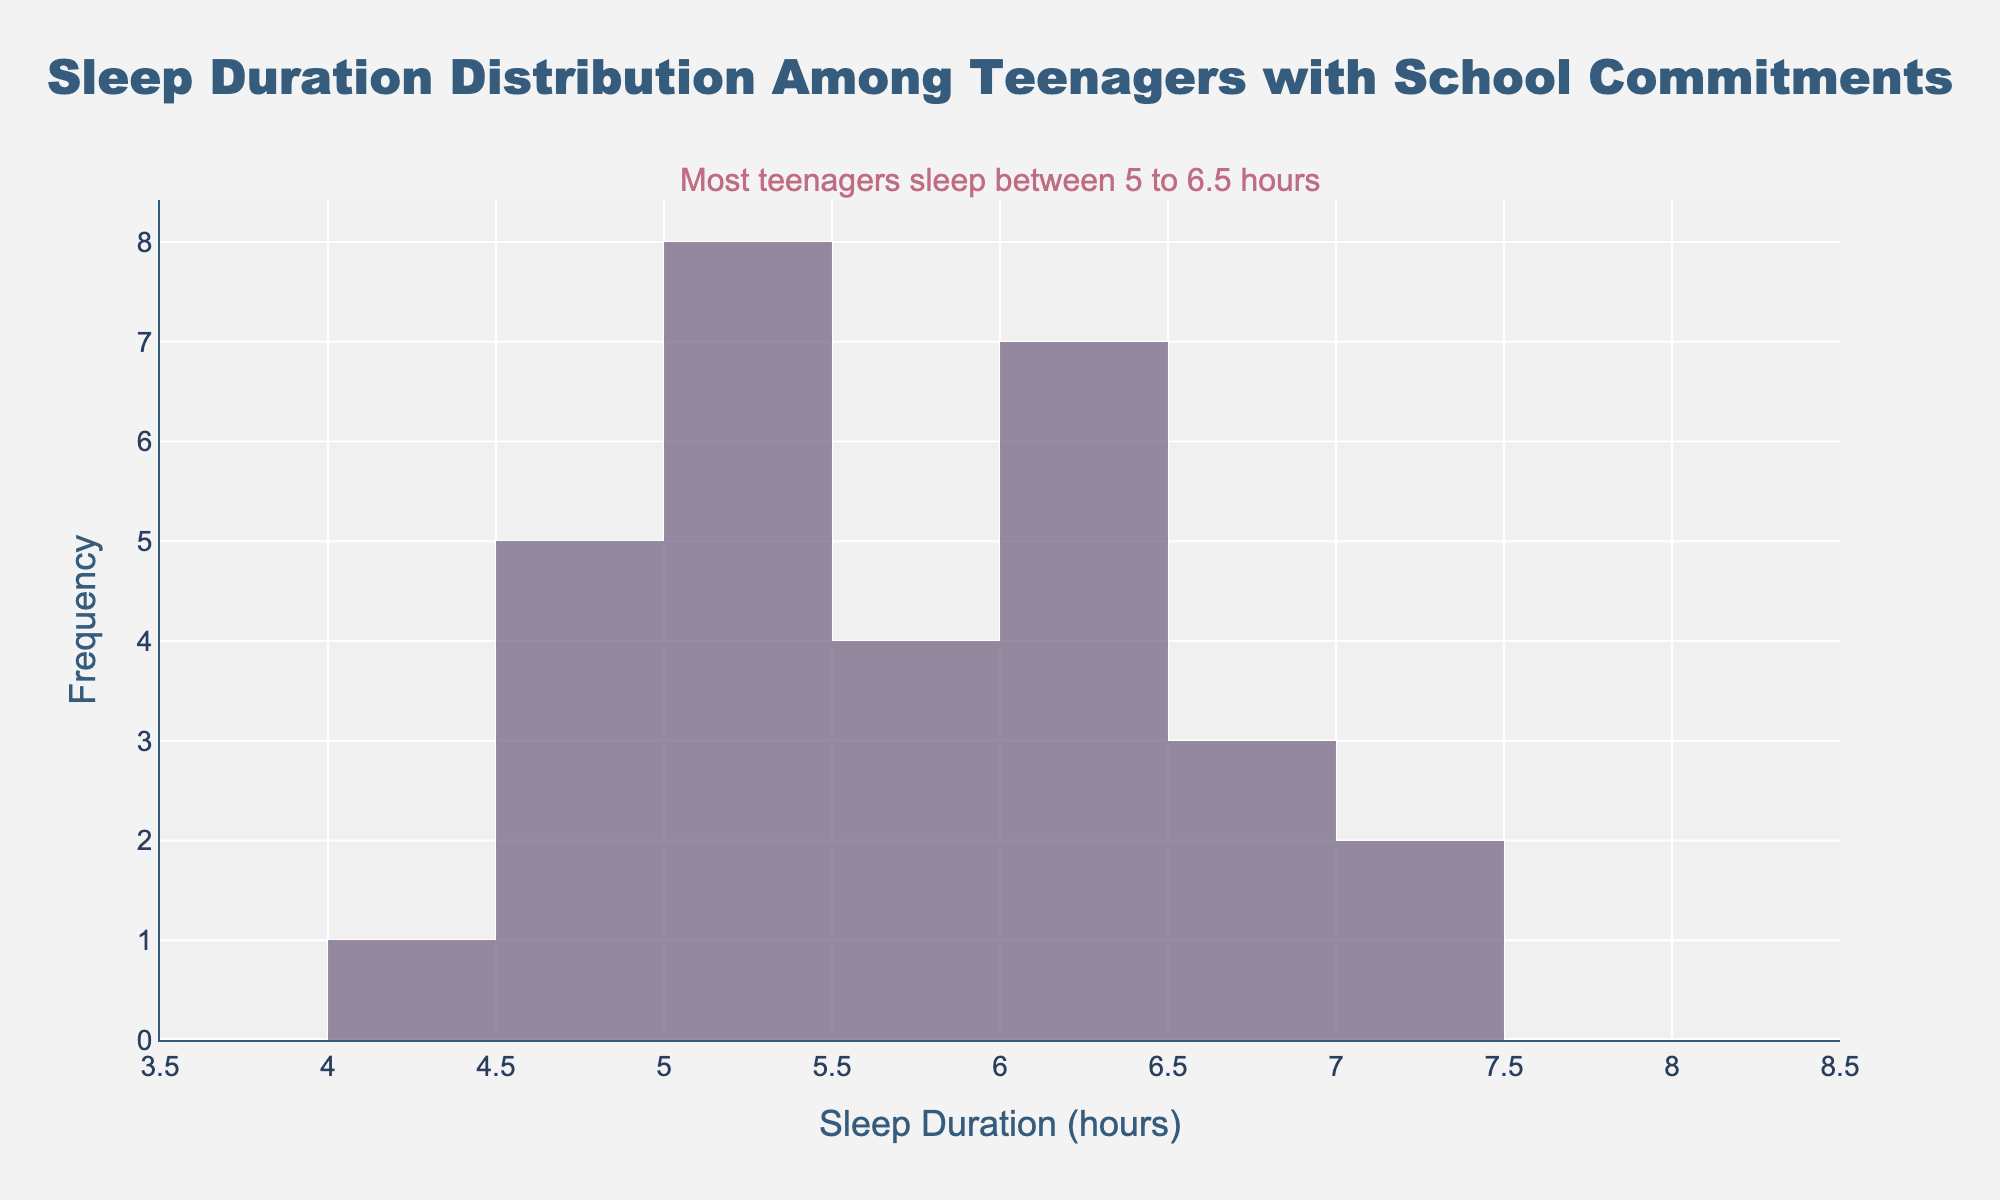What's the title of the figure? The figure's title is displayed at the top in bold font.
Answer: Sleep Duration Distribution Among Teenagers with School Commitments What is the most common range of sleep duration among the teenagers? Observing the figure, the annotation indicates that most teenagers sleep between 5 to 6.5 hours. This is also clear from the histogram where the bars are the highest between these values.
Answer: 5 to 6.5 hours How many bins are there in the histogram? To find the number of bins, count the number of bars along the x-axis, spaced by the bin size of 0.5 hours ranging from 4 to 8. There are 8 intervals in total.
Answer: 8 bins What does the annotation in the graph say? The annotation text is located at the top of the plot and provides an insight into the data distribution. It reads that most teenagers sleep between 5 to 6.5 hours.
Answer: Most teenagers sleep between 5 to 6.5 hours What is the range of the x-axis? The x-axis shows the range of sleep duration hours. It starts at 3.5 and ends at 8.5.
Answer: 3.5 to 8.5 hours What is the median sleep duration based on the violin plot? By observing the violin plot, which is directly above the x-axis labeled 'Sleep Duration', locate the thick black line inside the plot box, which represents the median. It lies approximately at 5.5 hours.
Answer: 5.5 hours Compare the sleep duration of teenagers with school commitments as displayed in the histogram. Which sleep duration appears to be the least common? By examining the histogram, the smallest bars correspond to the sleep durations at the extreme ends of the distribution, particularly around 4 and 8 hours, indicating these durations are the least common.
Answer: 4 and 8 hours How does the frequency of sleep durations between 5 and 6 hours compare to those between 4.5 and 5 hours? By comparing the height of the histogram bars, the frequencies of sleep durations are higher between 5 to 6 hours compared to 4.5 to 5 hours.
Answer: 5 to 6 hours have higher frequencies What color is used for the violin plot line and box? The violin plot line and box color is distinguished in the plot with a specific color. They are both in dark blue.
Answer: Dark blue What is the purpose of including both a histogram and a violin plot in this figure? The combined use of a histogram and a violin plot provides a comprehensive view of the data. The histogram shows the frequency of sleep durations in bins, while the violin plot shows the distribution's shape, central tendency, and variability.
Answer: To show frequency and distribution shape 